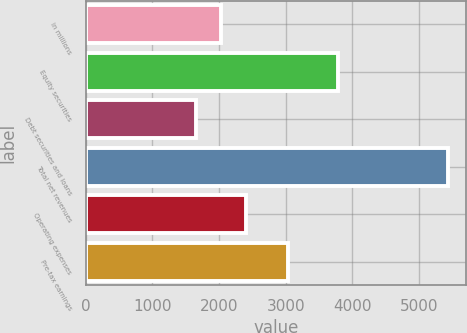Convert chart to OTSL. <chart><loc_0><loc_0><loc_500><loc_500><bar_chart><fcel>in millions<fcel>Equity securities<fcel>Debt securities and loans<fcel>Total net revenues<fcel>Operating expenses<fcel>Pre-tax earnings<nl><fcel>2033.1<fcel>3781<fcel>1655<fcel>5436<fcel>2411.2<fcel>3034<nl></chart> 